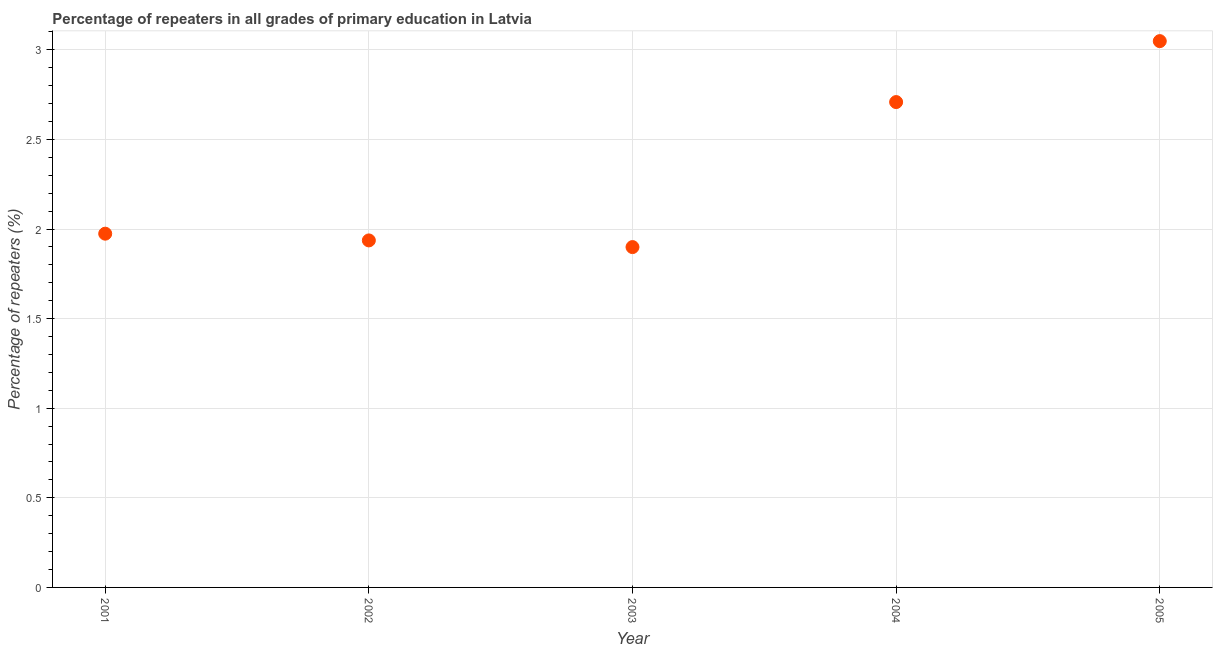What is the percentage of repeaters in primary education in 2001?
Your answer should be compact. 1.97. Across all years, what is the maximum percentage of repeaters in primary education?
Keep it short and to the point. 3.05. Across all years, what is the minimum percentage of repeaters in primary education?
Your response must be concise. 1.9. In which year was the percentage of repeaters in primary education minimum?
Your answer should be compact. 2003. What is the sum of the percentage of repeaters in primary education?
Your response must be concise. 11.57. What is the difference between the percentage of repeaters in primary education in 2001 and 2002?
Your answer should be compact. 0.04. What is the average percentage of repeaters in primary education per year?
Offer a terse response. 2.31. What is the median percentage of repeaters in primary education?
Your answer should be compact. 1.97. In how many years, is the percentage of repeaters in primary education greater than 0.1 %?
Keep it short and to the point. 5. What is the ratio of the percentage of repeaters in primary education in 2003 to that in 2004?
Provide a short and direct response. 0.7. Is the difference between the percentage of repeaters in primary education in 2001 and 2005 greater than the difference between any two years?
Ensure brevity in your answer.  No. What is the difference between the highest and the second highest percentage of repeaters in primary education?
Offer a terse response. 0.34. What is the difference between the highest and the lowest percentage of repeaters in primary education?
Your answer should be very brief. 1.15. How many dotlines are there?
Ensure brevity in your answer.  1. Are the values on the major ticks of Y-axis written in scientific E-notation?
Provide a short and direct response. No. Does the graph contain any zero values?
Make the answer very short. No. Does the graph contain grids?
Your answer should be very brief. Yes. What is the title of the graph?
Keep it short and to the point. Percentage of repeaters in all grades of primary education in Latvia. What is the label or title of the X-axis?
Make the answer very short. Year. What is the label or title of the Y-axis?
Make the answer very short. Percentage of repeaters (%). What is the Percentage of repeaters (%) in 2001?
Offer a very short reply. 1.97. What is the Percentage of repeaters (%) in 2002?
Keep it short and to the point. 1.94. What is the Percentage of repeaters (%) in 2003?
Provide a short and direct response. 1.9. What is the Percentage of repeaters (%) in 2004?
Ensure brevity in your answer.  2.71. What is the Percentage of repeaters (%) in 2005?
Your response must be concise. 3.05. What is the difference between the Percentage of repeaters (%) in 2001 and 2002?
Make the answer very short. 0.04. What is the difference between the Percentage of repeaters (%) in 2001 and 2003?
Provide a short and direct response. 0.07. What is the difference between the Percentage of repeaters (%) in 2001 and 2004?
Offer a very short reply. -0.73. What is the difference between the Percentage of repeaters (%) in 2001 and 2005?
Provide a succinct answer. -1.07. What is the difference between the Percentage of repeaters (%) in 2002 and 2003?
Your response must be concise. 0.04. What is the difference between the Percentage of repeaters (%) in 2002 and 2004?
Make the answer very short. -0.77. What is the difference between the Percentage of repeaters (%) in 2002 and 2005?
Your response must be concise. -1.11. What is the difference between the Percentage of repeaters (%) in 2003 and 2004?
Make the answer very short. -0.81. What is the difference between the Percentage of repeaters (%) in 2003 and 2005?
Offer a very short reply. -1.15. What is the difference between the Percentage of repeaters (%) in 2004 and 2005?
Offer a very short reply. -0.34. What is the ratio of the Percentage of repeaters (%) in 2001 to that in 2003?
Ensure brevity in your answer.  1.04. What is the ratio of the Percentage of repeaters (%) in 2001 to that in 2004?
Your answer should be compact. 0.73. What is the ratio of the Percentage of repeaters (%) in 2001 to that in 2005?
Offer a terse response. 0.65. What is the ratio of the Percentage of repeaters (%) in 2002 to that in 2003?
Keep it short and to the point. 1.02. What is the ratio of the Percentage of repeaters (%) in 2002 to that in 2004?
Make the answer very short. 0.71. What is the ratio of the Percentage of repeaters (%) in 2002 to that in 2005?
Make the answer very short. 0.64. What is the ratio of the Percentage of repeaters (%) in 2003 to that in 2004?
Provide a succinct answer. 0.7. What is the ratio of the Percentage of repeaters (%) in 2003 to that in 2005?
Make the answer very short. 0.62. What is the ratio of the Percentage of repeaters (%) in 2004 to that in 2005?
Ensure brevity in your answer.  0.89. 